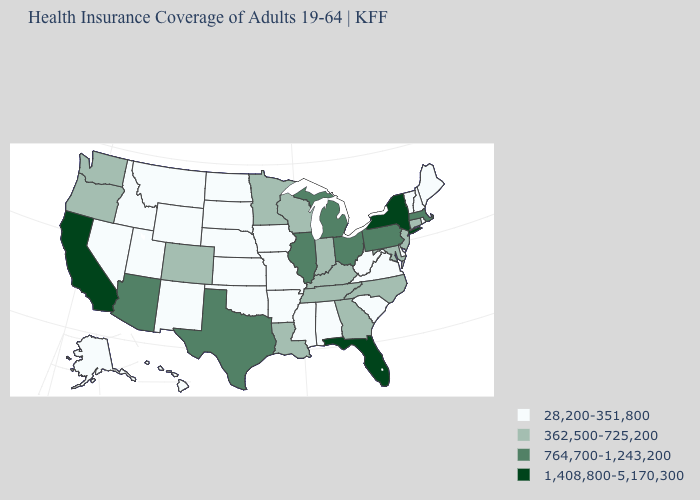Is the legend a continuous bar?
Be succinct. No. Name the states that have a value in the range 28,200-351,800?
Short answer required. Alabama, Alaska, Arkansas, Delaware, Hawaii, Idaho, Iowa, Kansas, Maine, Mississippi, Missouri, Montana, Nebraska, Nevada, New Hampshire, New Mexico, North Dakota, Oklahoma, Rhode Island, South Carolina, South Dakota, Utah, Vermont, Virginia, West Virginia, Wyoming. What is the value of Indiana?
Quick response, please. 362,500-725,200. Name the states that have a value in the range 362,500-725,200?
Keep it brief. Colorado, Connecticut, Georgia, Indiana, Kentucky, Louisiana, Maryland, Minnesota, New Jersey, North Carolina, Oregon, Tennessee, Washington, Wisconsin. What is the lowest value in the Northeast?
Be succinct. 28,200-351,800. Does Connecticut have a lower value than Michigan?
Answer briefly. Yes. What is the highest value in the USA?
Concise answer only. 1,408,800-5,170,300. What is the highest value in the West ?
Be succinct. 1,408,800-5,170,300. Which states have the highest value in the USA?
Quick response, please. California, Florida, New York. What is the value of Mississippi?
Quick response, please. 28,200-351,800. What is the highest value in states that border California?
Keep it brief. 764,700-1,243,200. Does Alaska have the lowest value in the West?
Concise answer only. Yes. What is the value of California?
Short answer required. 1,408,800-5,170,300. Name the states that have a value in the range 1,408,800-5,170,300?
Be succinct. California, Florida, New York. Does Louisiana have the highest value in the USA?
Keep it brief. No. 